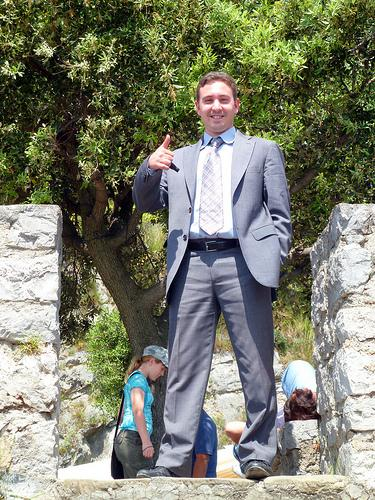Describe the man's shoes and belt. The man is wearing two black leather shoes and a black leather belt with a silver buckle. Create a product advertisement task based on the image. Dress to impress with our modern suit and eye-catching multicolored tie, perfect for work events, parties, or when you want to make a statement. Elevate your style today! What can you say about the environment where the people are? The people are surrounded by a white rock wall with a small plant growing in it, green trees, and other people sitting behind the man. Tell me about the girl standing behind the man. The girl is leaning on a tree, wearing a blue shirt, a faded camouflage hat, and carrying a black purse. Choose a question for the multi-choice VQA task: What color is the man's shirt beneath his jacket? Answers: (A) Black (B) Light Blue (C) White (B) Light Blue For the visual entailment task, describe something that could be implied from the image. The man in the suit might be at a social event or gathering, as the other people sitting behind him and the girl leaning on the tree are dressed casually. Which two people are wearing blue shirts? The man wearing a suit has a light blue shirt underneath his jacket, and the girl leaning on the tree also wears a blue shirt. What is unique about the tie the man in the suit is wearing? The tie has a plaid pattern and combines blue, red, and white colors. What are the man's clothes like and what is he doing? The man is wearing a suit with a blue, red, and white tie, grey pants, grey jacket, and black shoes, and he is gesturing and giving a thumbs up. 